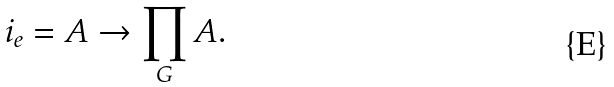<formula> <loc_0><loc_0><loc_500><loc_500>i _ { e } = A \to \prod _ { G } A .</formula> 